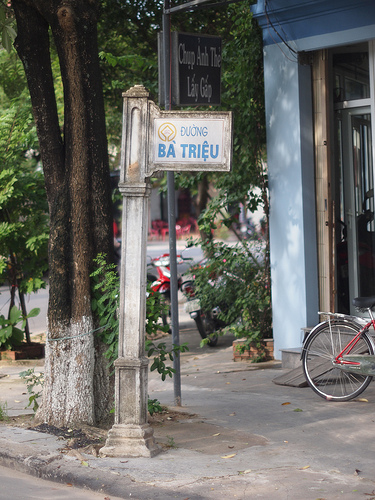Please provide the bounding box coordinate of the region this sentence describes: a leaf on the ground. The coordinates for the bounding box around the region described as a 'leaf on the ground' are approximately [0.56, 0.9, 0.6, 0.93]. 